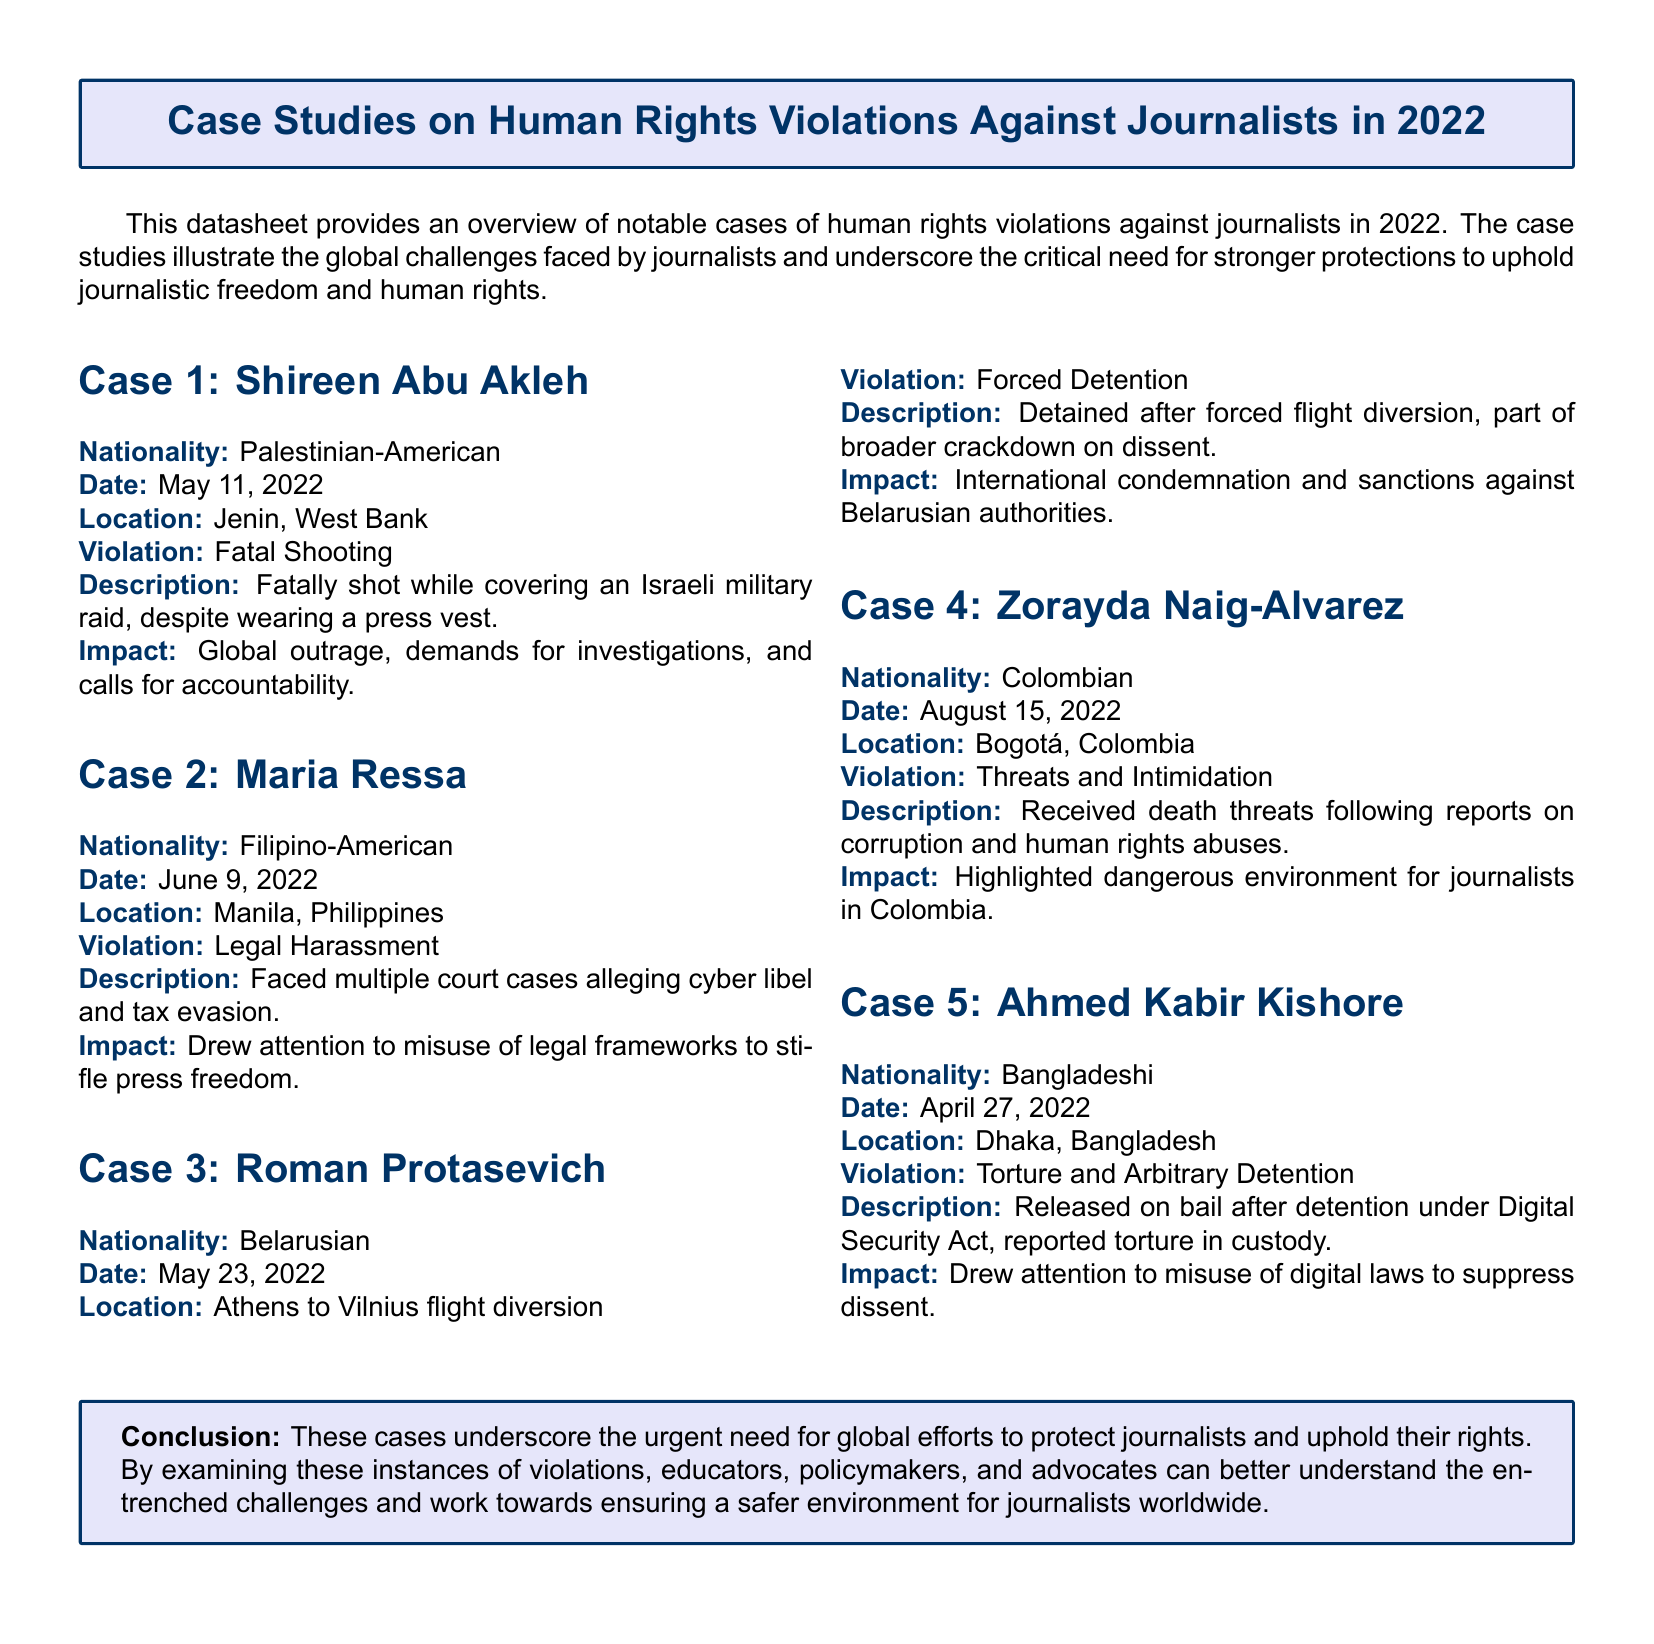What is the nationality of Shireen Abu Akleh? The nationality of Shireen Abu Akleh is specified in her case details.
Answer: Palestinian-American When was Maria Ressa faced with legal harassment? The date of Maria Ressa's legal harassment case is provided in the case study details.
Answer: June 9, 2022 What type of violation was Roman Protasevich subjected to? Roman Protasevich's case specifies the type of human rights violation he experienced.
Answer: Forced Detention What impact did the case of Ahmed Kabir Kishore have? The impact mentioned shows the significance of Ahmed Kabir Kishore's case regarding freedom of expression.
Answer: Drew attention to misuse of digital laws to suppress dissent Which journalist received death threats in Colombia? The case details clearly mention the journalist who encountered threats in Colombia.
Answer: Zorayda Naig-Alvarez What was the location of Shireen Abu Akleh's fatal shooting? The location of the incident involving Shireen Abu Akleh is stated in her case information.
Answer: Jenin, West Bank What were the allegations against Maria Ressa? The specific accusations faced by Maria Ressa are detailed in her case description.
Answer: Cyber libel and tax evasion What was the common theme highlighted in the conclusion? The conclusion summarizes the overarching issue faced by journalists worldwide, as highlighted in the document.
Answer: Urgent need for global efforts to protect journalists 